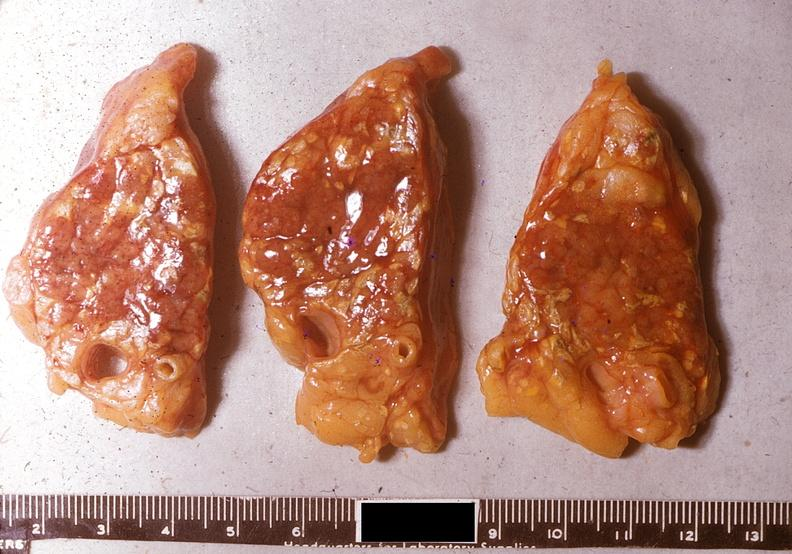what does this image show?
Answer the question using a single word or phrase. Acute pancreatitis 